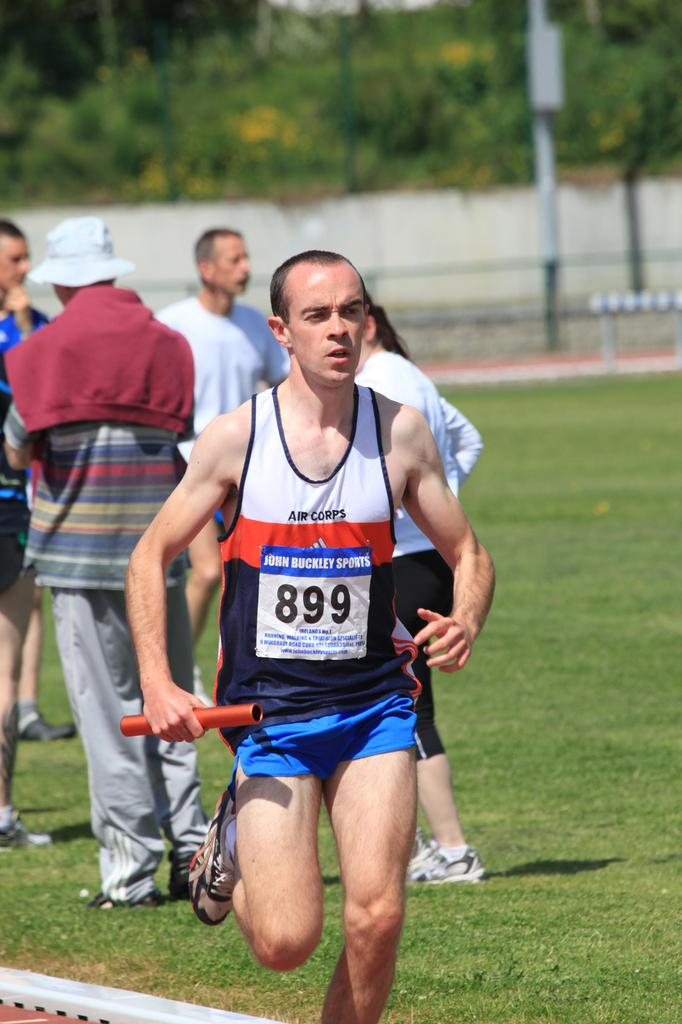<image>
Describe the image concisely. An athlete running with a baton and 899 on the chest. 